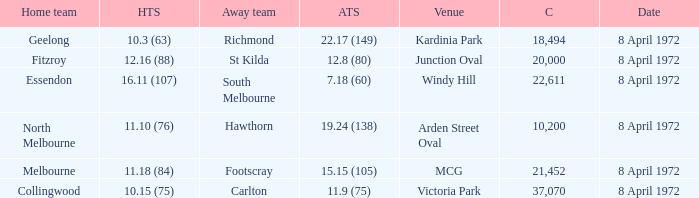Which Away team score has a Venue of kardinia park? 22.17 (149). 